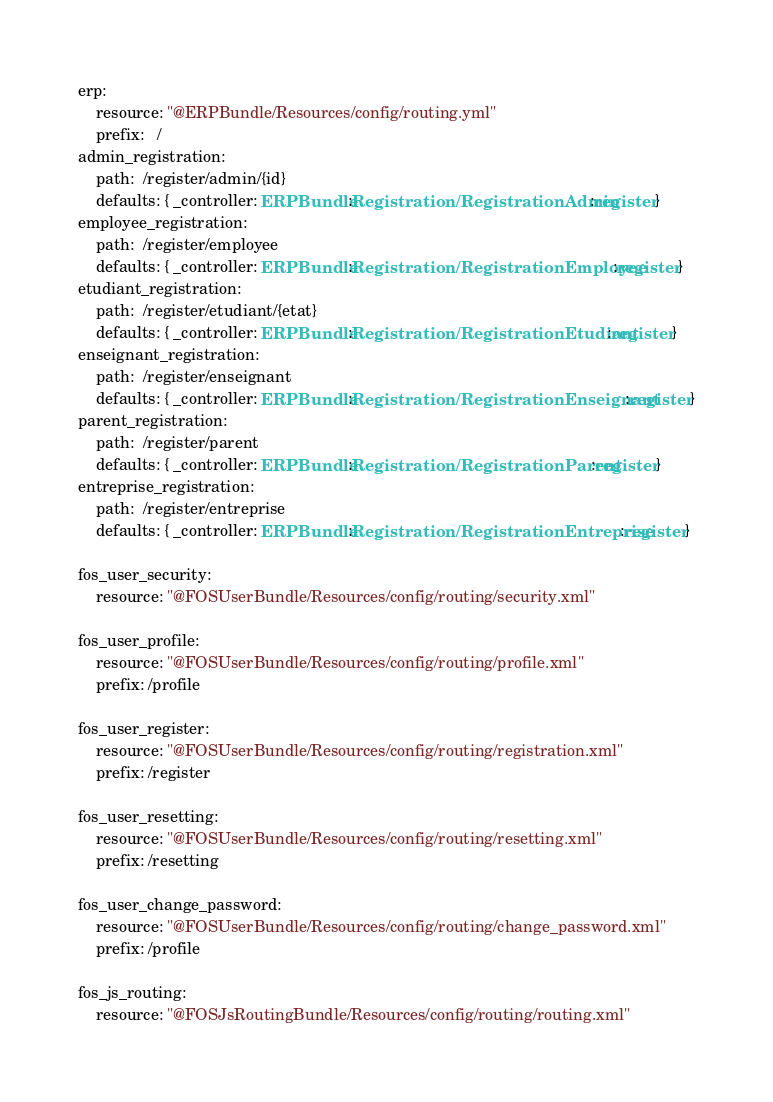<code> <loc_0><loc_0><loc_500><loc_500><_YAML_>erp:
    resource: "@ERPBundle/Resources/config/routing.yml"
    prefix:   /
admin_registration:
    path:  /register/admin/{id}
    defaults: { _controller: ERPBundle:Registration/RegistrationAdmin:register }
employee_registration:
    path:  /register/employee
    defaults: { _controller: ERPBundle:Registration/RegistrationEmployee:register }
etudiant_registration:
    path:  /register/etudiant/{etat}
    defaults: { _controller: ERPBundle:Registration/RegistrationEtudiant:register }
enseignant_registration:
    path:  /register/enseignant
    defaults: { _controller: ERPBundle:Registration/RegistrationEnseignant:register }
parent_registration:
    path:  /register/parent
    defaults: { _controller: ERPBundle:Registration/RegistrationParent:register }
entreprise_registration:
    path:  /register/entreprise
    defaults: { _controller: ERPBundle:Registration/RegistrationEntreprise:register }

fos_user_security:
    resource: "@FOSUserBundle/Resources/config/routing/security.xml"

fos_user_profile:
    resource: "@FOSUserBundle/Resources/config/routing/profile.xml"
    prefix: /profile

fos_user_register:
    resource: "@FOSUserBundle/Resources/config/routing/registration.xml"
    prefix: /register

fos_user_resetting:
    resource: "@FOSUserBundle/Resources/config/routing/resetting.xml"
    prefix: /resetting

fos_user_change_password:
    resource: "@FOSUserBundle/Resources/config/routing/change_password.xml"
    prefix: /profile

fos_js_routing:
    resource: "@FOSJsRoutingBundle/Resources/config/routing/routing.xml"

</code> 